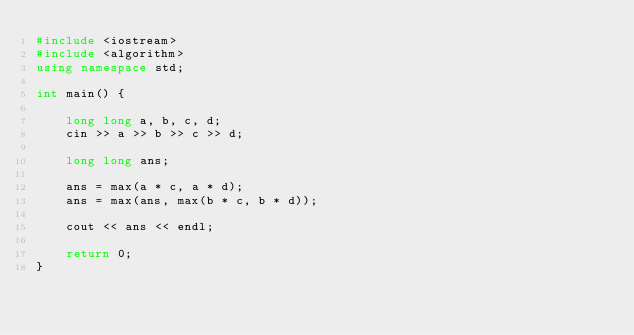Convert code to text. <code><loc_0><loc_0><loc_500><loc_500><_C++_>#include <iostream>
#include <algorithm>
using namespace std;

int main() {

    long long a, b, c, d;
    cin >> a >> b >> c >> d;

    long long ans;

    ans = max(a * c, a * d);
    ans = max(ans, max(b * c, b * d));

    cout << ans << endl;

    return 0;
}</code> 